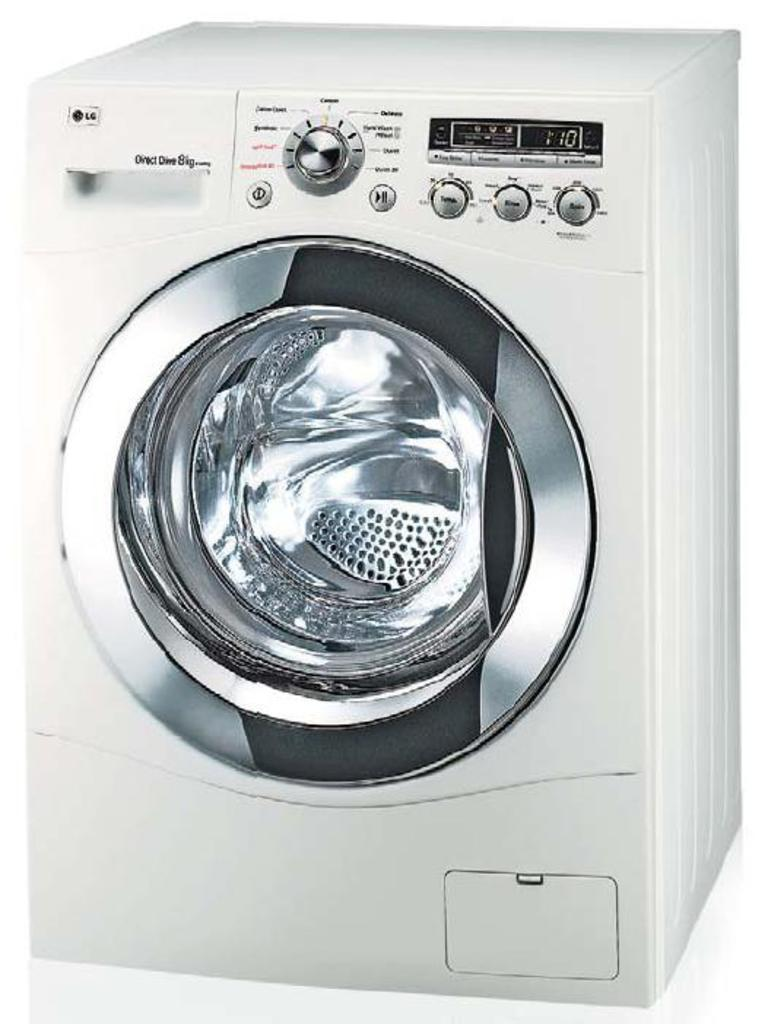What appliance can be seen in the image? There is a washing machine in the image. What is the primary function of the appliance in the image? The primary function of the washing machine is to clean clothes. Can you describe the appearance of the washing machine in the image? The image shows a washing machine, which typically has a door, a control panel, and a drum for holding clothes. How many cows are present in the image? There are no cows present in the image; it features a washing machine. What type of yoke is used to control the washing machine in the image? There is no yoke present in the image, as yokes are typically associated with animals or farming equipment, not washing machines. 